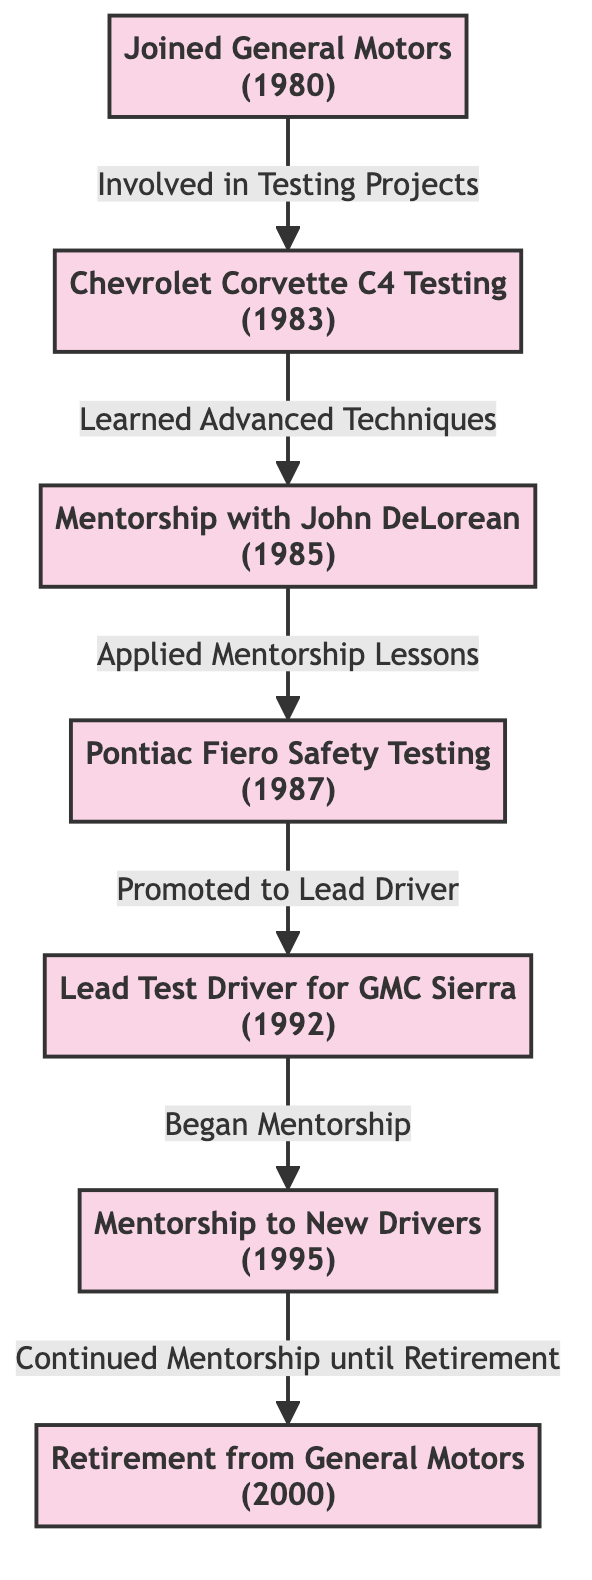What is the first event in the career timeline? The first event in the timeline is "Joined General Motors," which is the starting point of the directed graph. This node is the only one with no incoming edges, indicating it is the beginning of the career journey.
Answer: Joined General Motors How many mentorship connections are shown in the diagram? There are two mentorship connections indicated in the diagram: "Mentorship with John DeLorean" and "Mentorship to New Drivers." These nodes represent key mentorship moments in the career, and can be counted from the diagram.
Answer: 2 Which project followed the Chevrolet Corvette C4 Testing? The project that followed "Chevrolet Corvette C4 Testing" is "Mentorship with John DeLorean." This can be determined by following the directed edge from the Chevrolet Corvette C4 Testing node to the mentorship node.
Answer: Mentorship with John DeLorean In what year did the individual start mentorship to new drivers? The individual started mentoring new drivers in 1995, as indicated directly below the "Mentorship to New Drivers" node in the diagram, which shows the year clearly.
Answer: 1995 What was the result of the Pontiac Fiero Safety Testing? The result of the Pontiac Fiero Safety Testing, according to the diagram, was a promotion to Lead Test Driver for GMC Sierra, which is shown as the next node following the safety testing node.
Answer: Promoted to Lead Driver How does the diagram depict the progression of the individual's career? The diagram depicts the progression of the individual's career as a series of connected nodes. Each node represents a career milestone, leading to the next, demonstrating a logical flow from joining General Motors to retirement, with mentorship connections included.
Answer: A series of connected nodes What label connects the "Lead Test Driver for GMC Sierra" to "Mentorship to New Drivers"? The label connecting these two nodes is "Began Mentorship," indicating the action or relationship that transitions from being a lead driver to engaging in mentorship for new drivers, as shown in the directed edge.
Answer: Began Mentorship Which event occurred last before the retirement? The last event before retirement was "Mentorship to New Drivers." This is the final node that connects to the retirement node, indicating the point just before the individual left General Motors.
Answer: Mentorship to New Drivers 